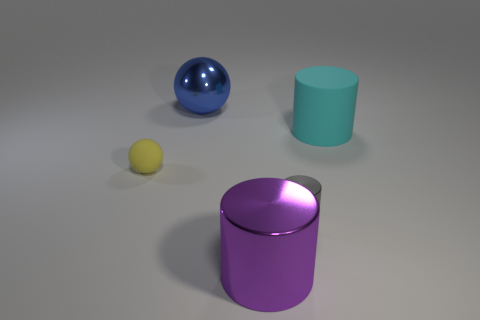Subtract all gray shiny cylinders. How many cylinders are left? 2 Subtract 2 balls. How many balls are left? 0 Subtract all balls. How many objects are left? 3 Subtract all cyan cylinders. How many cylinders are left? 2 Subtract 0 purple blocks. How many objects are left? 5 Subtract all purple spheres. Subtract all yellow blocks. How many spheres are left? 2 Subtract all purple spheres. How many gray cylinders are left? 1 Subtract all small yellow matte things. Subtract all gray shiny things. How many objects are left? 3 Add 1 big purple shiny cylinders. How many big purple shiny cylinders are left? 2 Add 5 tiny green metal balls. How many tiny green metal balls exist? 5 